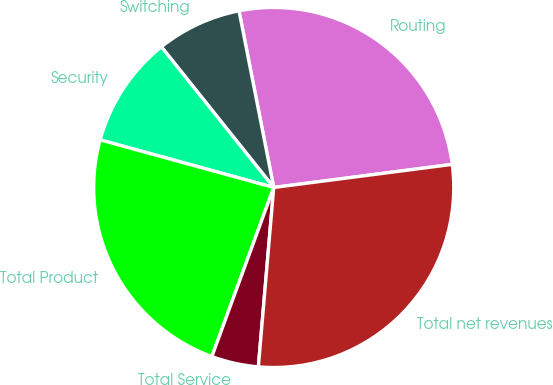<chart> <loc_0><loc_0><loc_500><loc_500><pie_chart><fcel>Routing<fcel>Switching<fcel>Security<fcel>Total Product<fcel>Total Service<fcel>Total net revenues<nl><fcel>26.04%<fcel>7.64%<fcel>10.01%<fcel>23.68%<fcel>4.22%<fcel>28.41%<nl></chart> 